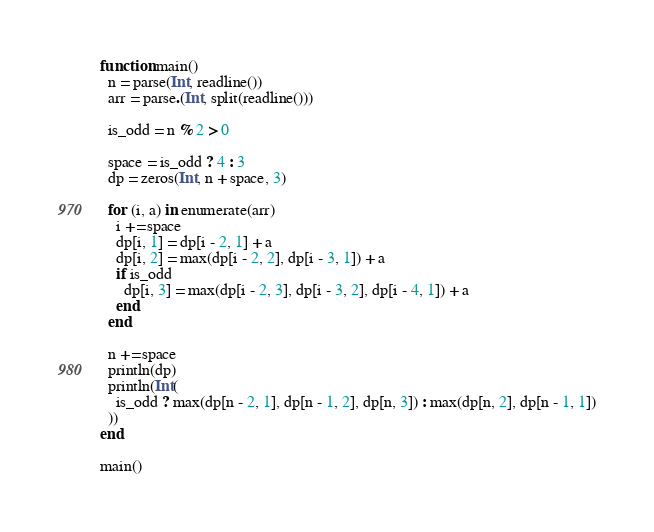<code> <loc_0><loc_0><loc_500><loc_500><_Julia_>
function main()
  n = parse(Int, readline())
  arr = parse.(Int, split(readline()))

  is_odd = n % 2 > 0

  space = is_odd ? 4 : 3
  dp = zeros(Int, n + space, 3)

  for (i, a) in enumerate(arr)
    i += space
    dp[i, 1] = dp[i - 2, 1] + a
    dp[i, 2] = max(dp[i - 2, 2], dp[i - 3, 1]) + a
    if is_odd
      dp[i, 3] = max(dp[i - 2, 3], dp[i - 3, 2], dp[i - 4, 1]) + a
    end
  end

  n += space
  println(dp)
  println(Int(
    is_odd ? max(dp[n - 2, 1], dp[n - 1, 2], dp[n, 3]) : max(dp[n, 2], dp[n - 1, 1])
  ))
end

main()
</code> 